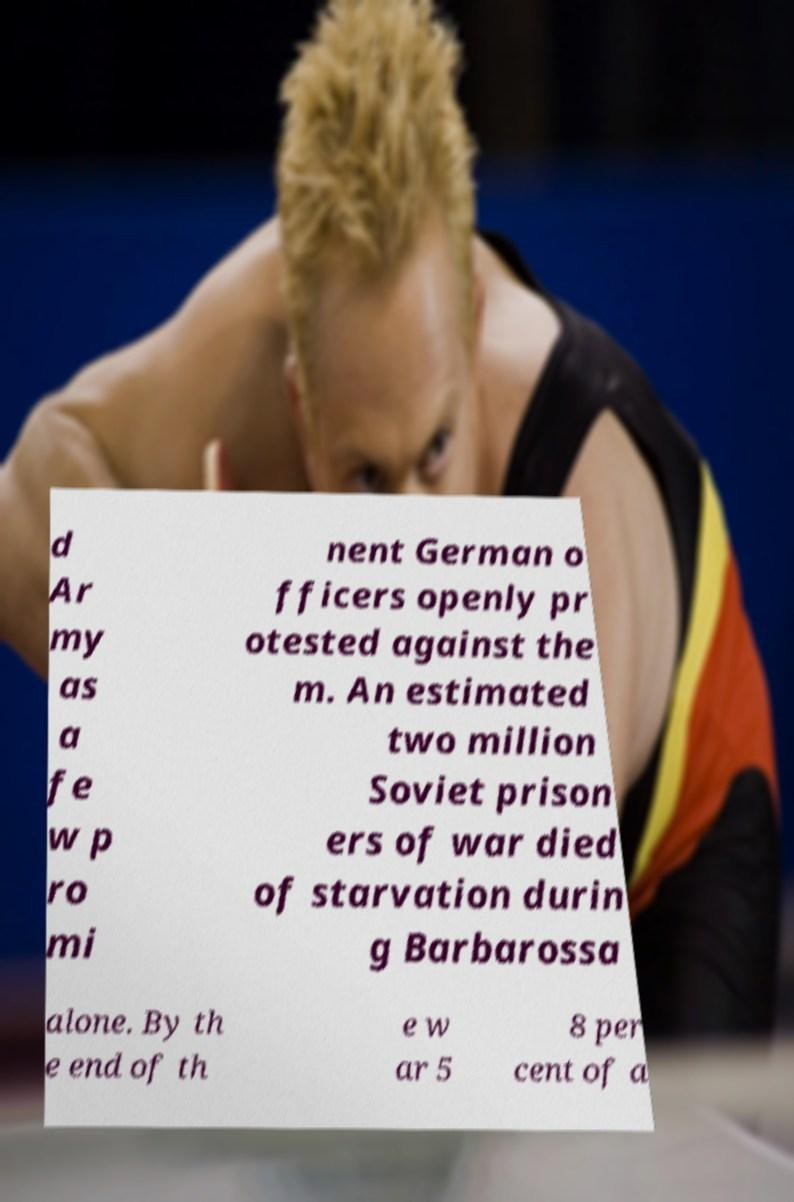For documentation purposes, I need the text within this image transcribed. Could you provide that? d Ar my as a fe w p ro mi nent German o fficers openly pr otested against the m. An estimated two million Soviet prison ers of war died of starvation durin g Barbarossa alone. By th e end of th e w ar 5 8 per cent of a 